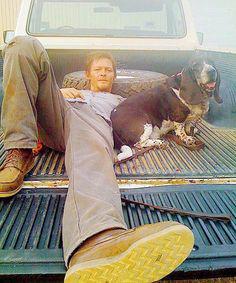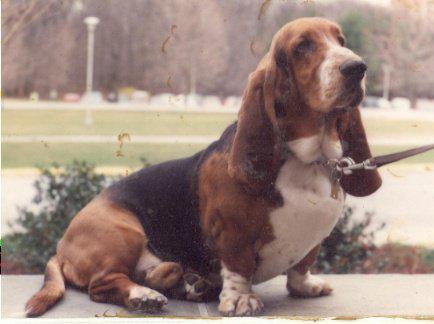The first image is the image on the left, the second image is the image on the right. For the images shown, is this caption "An image shows at least one dog wearing a hat associated with an ingestible product that is also pictured." true? Answer yes or no. No. The first image is the image on the left, the second image is the image on the right. Given the left and right images, does the statement "There are two dogs in total." hold true? Answer yes or no. Yes. 